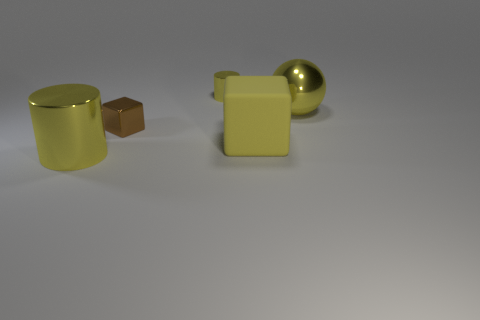Add 4 small objects. How many objects exist? 9 Subtract all cylinders. How many objects are left? 3 Add 3 large shiny things. How many large shiny things are left? 5 Add 3 large green rubber cylinders. How many large green rubber cylinders exist? 3 Subtract 0 red blocks. How many objects are left? 5 Subtract all tiny purple matte objects. Subtract all yellow objects. How many objects are left? 1 